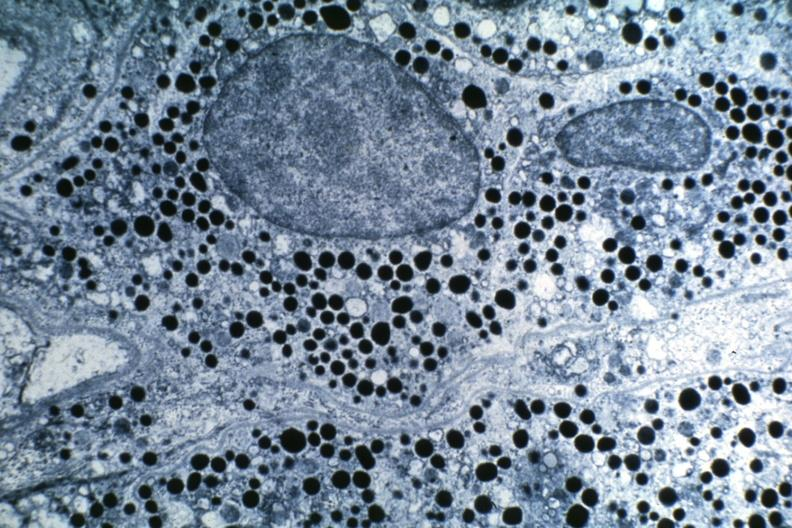s endocrine present?
Answer the question using a single word or phrase. Yes 